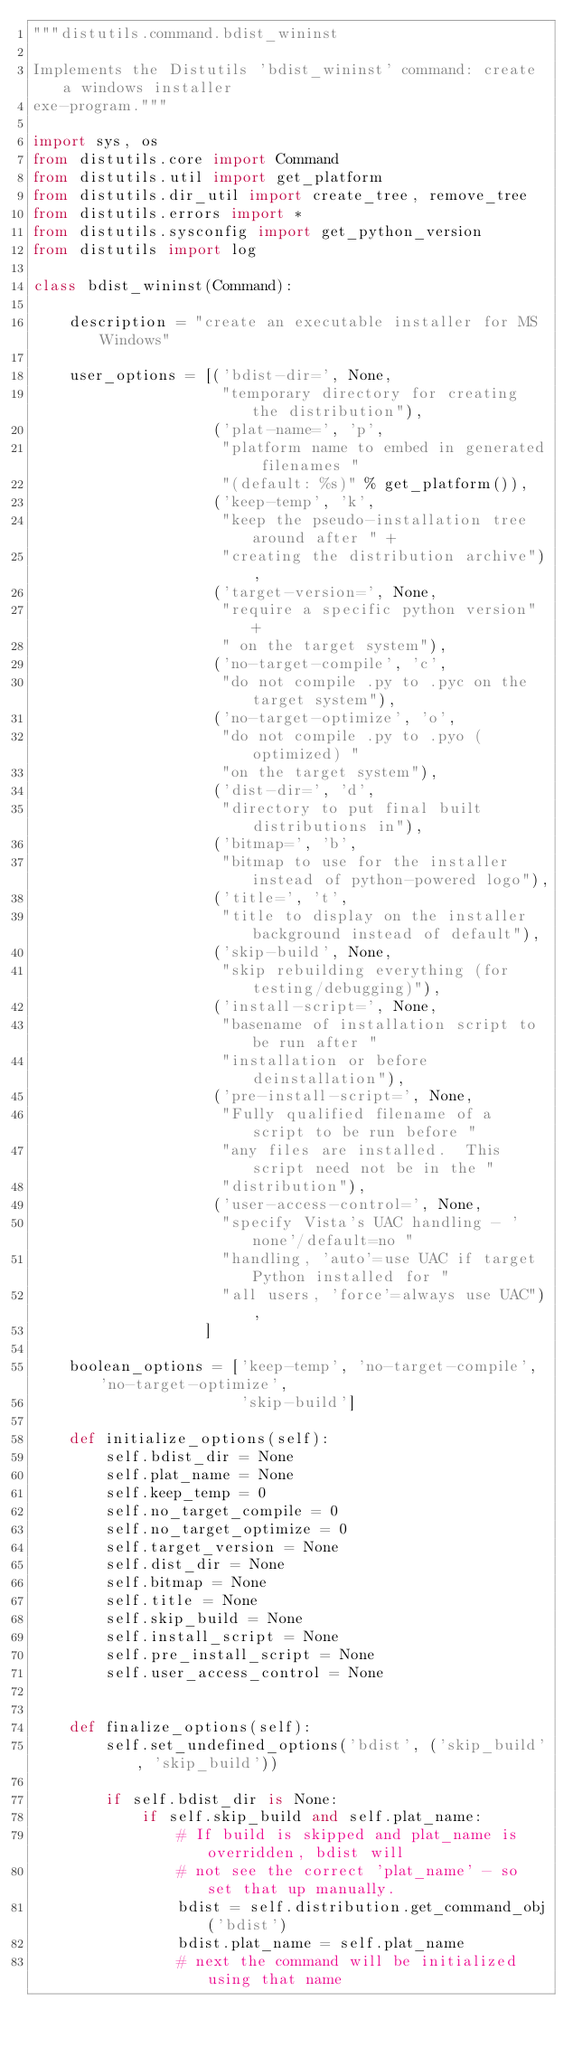<code> <loc_0><loc_0><loc_500><loc_500><_Python_>"""distutils.command.bdist_wininst

Implements the Distutils 'bdist_wininst' command: create a windows installer
exe-program."""

import sys, os
from distutils.core import Command
from distutils.util import get_platform
from distutils.dir_util import create_tree, remove_tree
from distutils.errors import *
from distutils.sysconfig import get_python_version
from distutils import log

class bdist_wininst(Command):

    description = "create an executable installer for MS Windows"

    user_options = [('bdist-dir=', None,
                     "temporary directory for creating the distribution"),
                    ('plat-name=', 'p',
                     "platform name to embed in generated filenames "
                     "(default: %s)" % get_platform()),
                    ('keep-temp', 'k',
                     "keep the pseudo-installation tree around after " +
                     "creating the distribution archive"),
                    ('target-version=', None,
                     "require a specific python version" +
                     " on the target system"),
                    ('no-target-compile', 'c',
                     "do not compile .py to .pyc on the target system"),
                    ('no-target-optimize', 'o',
                     "do not compile .py to .pyo (optimized) "
                     "on the target system"),
                    ('dist-dir=', 'd',
                     "directory to put final built distributions in"),
                    ('bitmap=', 'b',
                     "bitmap to use for the installer instead of python-powered logo"),
                    ('title=', 't',
                     "title to display on the installer background instead of default"),
                    ('skip-build', None,
                     "skip rebuilding everything (for testing/debugging)"),
                    ('install-script=', None,
                     "basename of installation script to be run after "
                     "installation or before deinstallation"),
                    ('pre-install-script=', None,
                     "Fully qualified filename of a script to be run before "
                     "any files are installed.  This script need not be in the "
                     "distribution"),
                    ('user-access-control=', None,
                     "specify Vista's UAC handling - 'none'/default=no "
                     "handling, 'auto'=use UAC if target Python installed for "
                     "all users, 'force'=always use UAC"),
                   ]

    boolean_options = ['keep-temp', 'no-target-compile', 'no-target-optimize',
                       'skip-build']

    def initialize_options(self):
        self.bdist_dir = None
        self.plat_name = None
        self.keep_temp = 0
        self.no_target_compile = 0
        self.no_target_optimize = 0
        self.target_version = None
        self.dist_dir = None
        self.bitmap = None
        self.title = None
        self.skip_build = None
        self.install_script = None
        self.pre_install_script = None
        self.user_access_control = None


    def finalize_options(self):
        self.set_undefined_options('bdist', ('skip_build', 'skip_build'))

        if self.bdist_dir is None:
            if self.skip_build and self.plat_name:
                # If build is skipped and plat_name is overridden, bdist will
                # not see the correct 'plat_name' - so set that up manually.
                bdist = self.distribution.get_command_obj('bdist')
                bdist.plat_name = self.plat_name
                # next the command will be initialized using that name</code> 